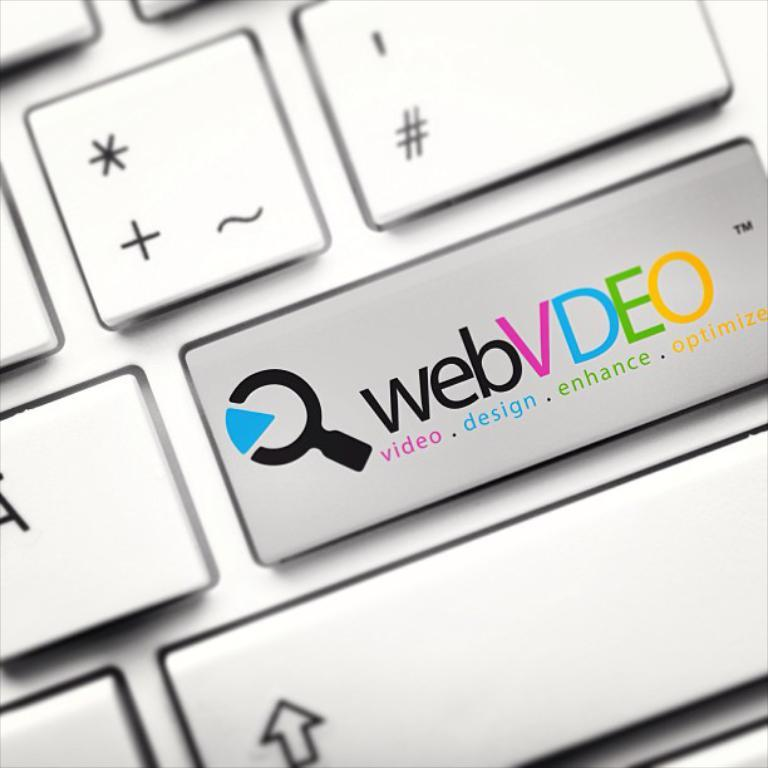Provide a one-sentence caption for the provided image. A keyboard key has webVDEO video.design.enhance.optimize on it. 